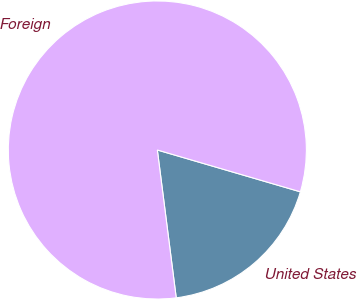<chart> <loc_0><loc_0><loc_500><loc_500><pie_chart><fcel>United States<fcel>Foreign<nl><fcel>18.45%<fcel>81.55%<nl></chart> 